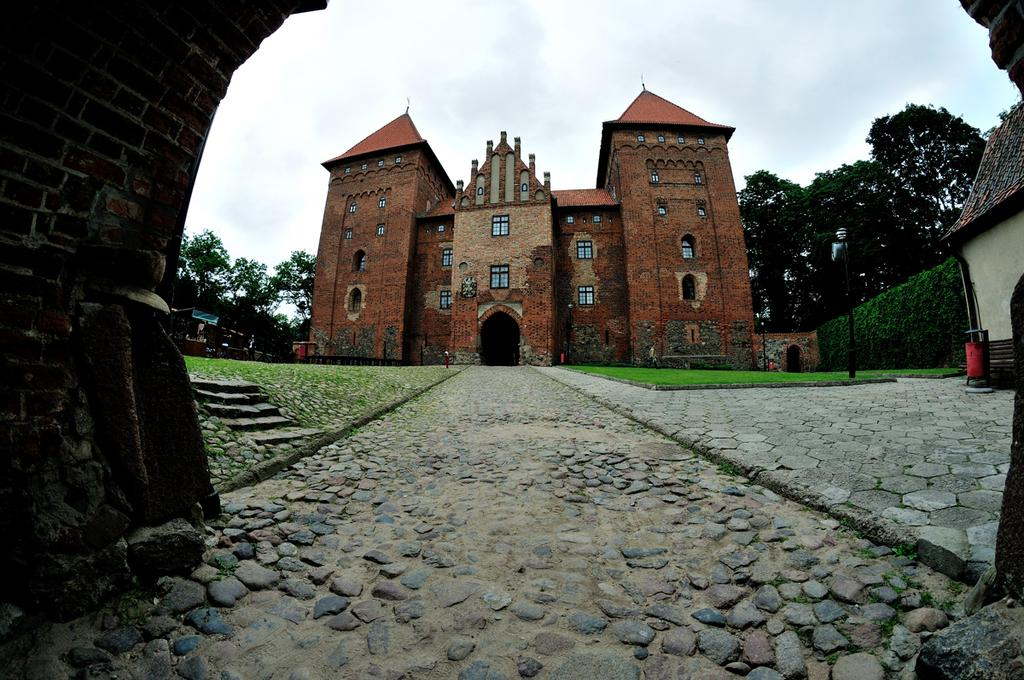What type of structures can be seen in the image? There are buildings in the image. What type of vegetation is visible in the image? There is grass and trees visible in the image. What is visible at the top of the image? The sky is visible at the top of the image. What is the purpose of the eggnog in the image? There is no eggnog present in the image. How many chairs are visible in the image? There is no reference to chairs in the image. 